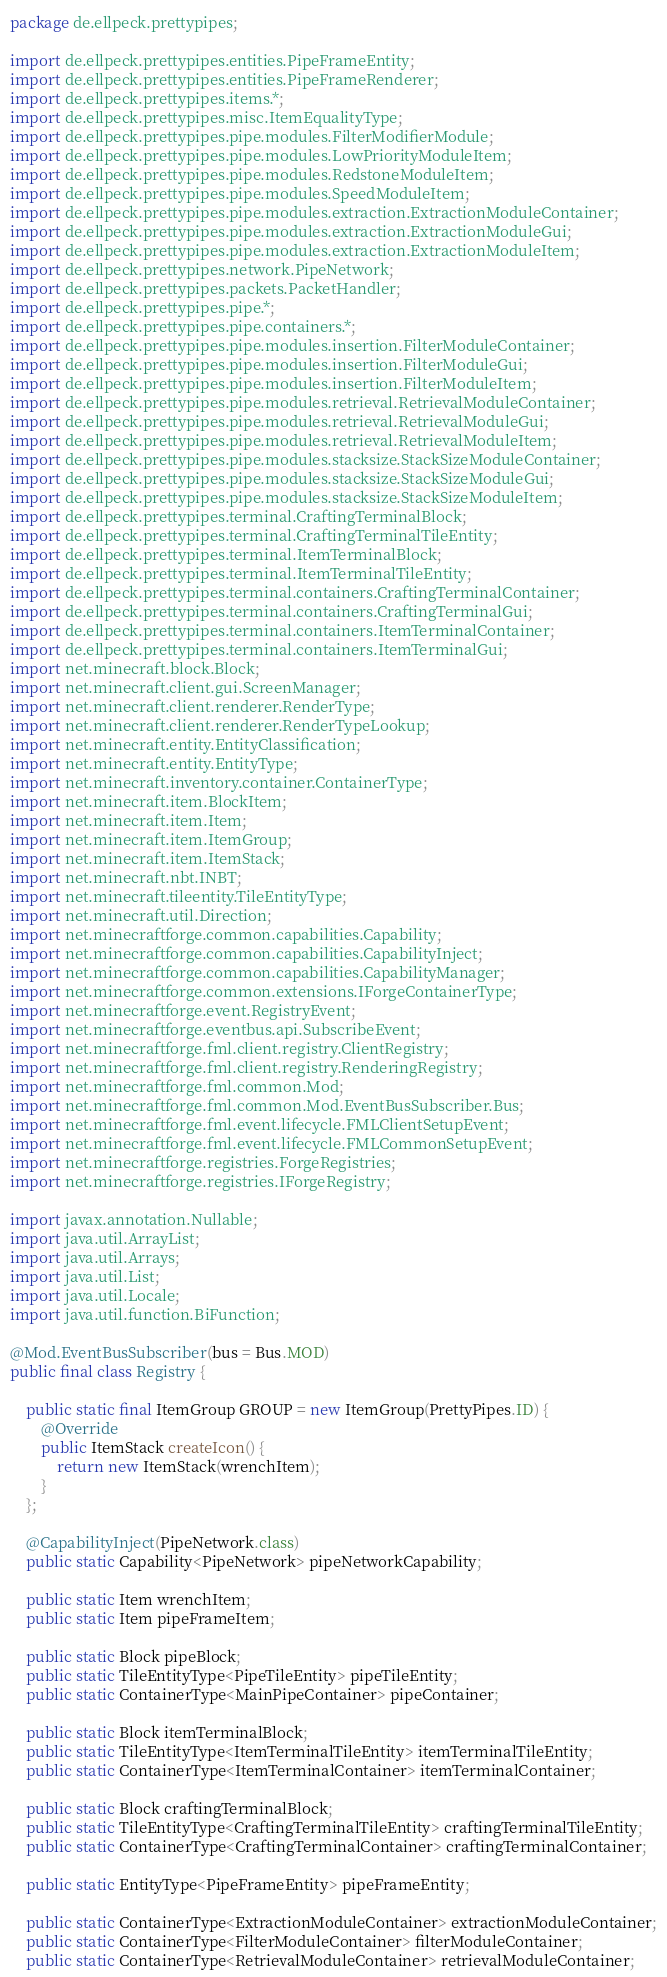Convert code to text. <code><loc_0><loc_0><loc_500><loc_500><_Java_>package de.ellpeck.prettypipes;

import de.ellpeck.prettypipes.entities.PipeFrameEntity;
import de.ellpeck.prettypipes.entities.PipeFrameRenderer;
import de.ellpeck.prettypipes.items.*;
import de.ellpeck.prettypipes.misc.ItemEqualityType;
import de.ellpeck.prettypipes.pipe.modules.FilterModifierModule;
import de.ellpeck.prettypipes.pipe.modules.LowPriorityModuleItem;
import de.ellpeck.prettypipes.pipe.modules.RedstoneModuleItem;
import de.ellpeck.prettypipes.pipe.modules.SpeedModuleItem;
import de.ellpeck.prettypipes.pipe.modules.extraction.ExtractionModuleContainer;
import de.ellpeck.prettypipes.pipe.modules.extraction.ExtractionModuleGui;
import de.ellpeck.prettypipes.pipe.modules.extraction.ExtractionModuleItem;
import de.ellpeck.prettypipes.network.PipeNetwork;
import de.ellpeck.prettypipes.packets.PacketHandler;
import de.ellpeck.prettypipes.pipe.*;
import de.ellpeck.prettypipes.pipe.containers.*;
import de.ellpeck.prettypipes.pipe.modules.insertion.FilterModuleContainer;
import de.ellpeck.prettypipes.pipe.modules.insertion.FilterModuleGui;
import de.ellpeck.prettypipes.pipe.modules.insertion.FilterModuleItem;
import de.ellpeck.prettypipes.pipe.modules.retrieval.RetrievalModuleContainer;
import de.ellpeck.prettypipes.pipe.modules.retrieval.RetrievalModuleGui;
import de.ellpeck.prettypipes.pipe.modules.retrieval.RetrievalModuleItem;
import de.ellpeck.prettypipes.pipe.modules.stacksize.StackSizeModuleContainer;
import de.ellpeck.prettypipes.pipe.modules.stacksize.StackSizeModuleGui;
import de.ellpeck.prettypipes.pipe.modules.stacksize.StackSizeModuleItem;
import de.ellpeck.prettypipes.terminal.CraftingTerminalBlock;
import de.ellpeck.prettypipes.terminal.CraftingTerminalTileEntity;
import de.ellpeck.prettypipes.terminal.ItemTerminalBlock;
import de.ellpeck.prettypipes.terminal.ItemTerminalTileEntity;
import de.ellpeck.prettypipes.terminal.containers.CraftingTerminalContainer;
import de.ellpeck.prettypipes.terminal.containers.CraftingTerminalGui;
import de.ellpeck.prettypipes.terminal.containers.ItemTerminalContainer;
import de.ellpeck.prettypipes.terminal.containers.ItemTerminalGui;
import net.minecraft.block.Block;
import net.minecraft.client.gui.ScreenManager;
import net.minecraft.client.renderer.RenderType;
import net.minecraft.client.renderer.RenderTypeLookup;
import net.minecraft.entity.EntityClassification;
import net.minecraft.entity.EntityType;
import net.minecraft.inventory.container.ContainerType;
import net.minecraft.item.BlockItem;
import net.minecraft.item.Item;
import net.minecraft.item.ItemGroup;
import net.minecraft.item.ItemStack;
import net.minecraft.nbt.INBT;
import net.minecraft.tileentity.TileEntityType;
import net.minecraft.util.Direction;
import net.minecraftforge.common.capabilities.Capability;
import net.minecraftforge.common.capabilities.CapabilityInject;
import net.minecraftforge.common.capabilities.CapabilityManager;
import net.minecraftforge.common.extensions.IForgeContainerType;
import net.minecraftforge.event.RegistryEvent;
import net.minecraftforge.eventbus.api.SubscribeEvent;
import net.minecraftforge.fml.client.registry.ClientRegistry;
import net.minecraftforge.fml.client.registry.RenderingRegistry;
import net.minecraftforge.fml.common.Mod;
import net.minecraftforge.fml.common.Mod.EventBusSubscriber.Bus;
import net.minecraftforge.fml.event.lifecycle.FMLClientSetupEvent;
import net.minecraftforge.fml.event.lifecycle.FMLCommonSetupEvent;
import net.minecraftforge.registries.ForgeRegistries;
import net.minecraftforge.registries.IForgeRegistry;

import javax.annotation.Nullable;
import java.util.ArrayList;
import java.util.Arrays;
import java.util.List;
import java.util.Locale;
import java.util.function.BiFunction;

@Mod.EventBusSubscriber(bus = Bus.MOD)
public final class Registry {

    public static final ItemGroup GROUP = new ItemGroup(PrettyPipes.ID) {
        @Override
        public ItemStack createIcon() {
            return new ItemStack(wrenchItem);
        }
    };

    @CapabilityInject(PipeNetwork.class)
    public static Capability<PipeNetwork> pipeNetworkCapability;

    public static Item wrenchItem;
    public static Item pipeFrameItem;

    public static Block pipeBlock;
    public static TileEntityType<PipeTileEntity> pipeTileEntity;
    public static ContainerType<MainPipeContainer> pipeContainer;

    public static Block itemTerminalBlock;
    public static TileEntityType<ItemTerminalTileEntity> itemTerminalTileEntity;
    public static ContainerType<ItemTerminalContainer> itemTerminalContainer;

    public static Block craftingTerminalBlock;
    public static TileEntityType<CraftingTerminalTileEntity> craftingTerminalTileEntity;
    public static ContainerType<CraftingTerminalContainer> craftingTerminalContainer;

    public static EntityType<PipeFrameEntity> pipeFrameEntity;

    public static ContainerType<ExtractionModuleContainer> extractionModuleContainer;
    public static ContainerType<FilterModuleContainer> filterModuleContainer;
    public static ContainerType<RetrievalModuleContainer> retrievalModuleContainer;</code> 